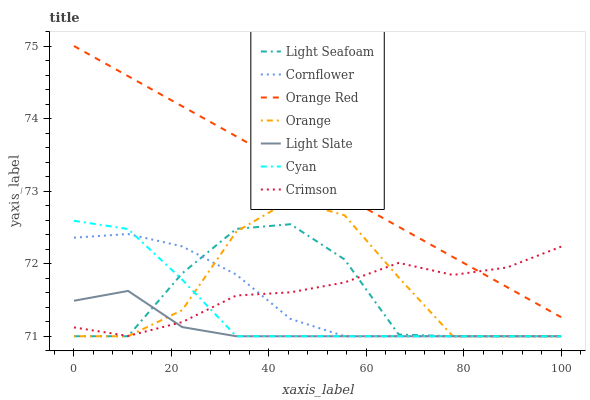Does Light Slate have the minimum area under the curve?
Answer yes or no. Yes. Does Orange Red have the maximum area under the curve?
Answer yes or no. Yes. Does Crimson have the minimum area under the curve?
Answer yes or no. No. Does Crimson have the maximum area under the curve?
Answer yes or no. No. Is Orange Red the smoothest?
Answer yes or no. Yes. Is Orange the roughest?
Answer yes or no. Yes. Is Light Slate the smoothest?
Answer yes or no. No. Is Light Slate the roughest?
Answer yes or no. No. Does Cornflower have the lowest value?
Answer yes or no. Yes. Does Crimson have the lowest value?
Answer yes or no. No. Does Orange Red have the highest value?
Answer yes or no. Yes. Does Crimson have the highest value?
Answer yes or no. No. Is Cornflower less than Orange Red?
Answer yes or no. Yes. Is Orange Red greater than Light Slate?
Answer yes or no. Yes. Does Light Slate intersect Crimson?
Answer yes or no. Yes. Is Light Slate less than Crimson?
Answer yes or no. No. Is Light Slate greater than Crimson?
Answer yes or no. No. Does Cornflower intersect Orange Red?
Answer yes or no. No. 